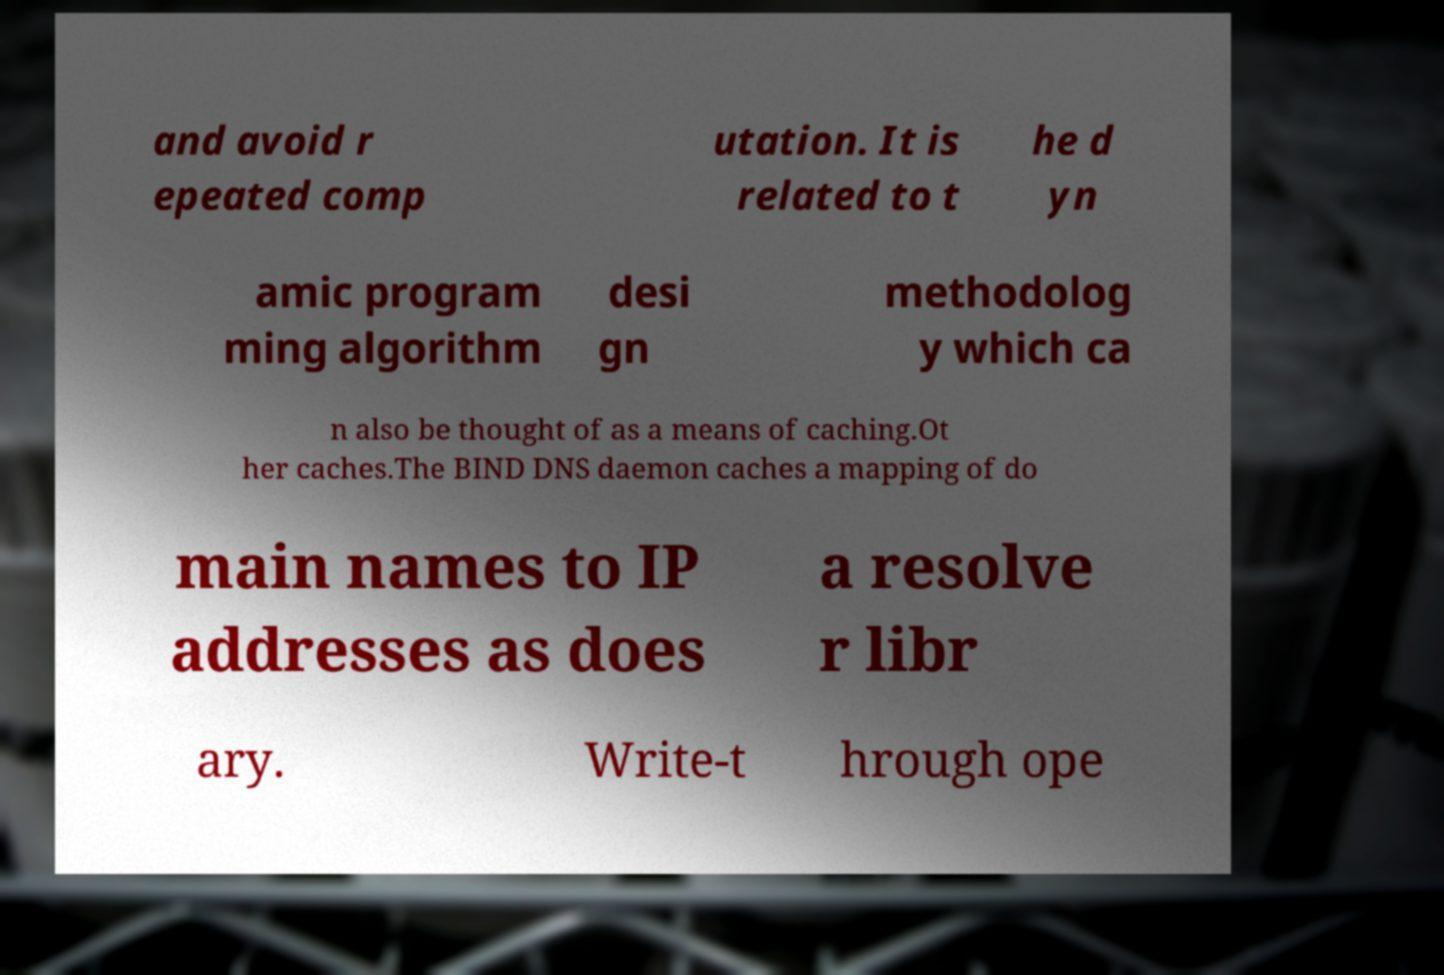For documentation purposes, I need the text within this image transcribed. Could you provide that? and avoid r epeated comp utation. It is related to t he d yn amic program ming algorithm desi gn methodolog y which ca n also be thought of as a means of caching.Ot her caches.The BIND DNS daemon caches a mapping of do main names to IP addresses as does a resolve r libr ary. Write-t hrough ope 